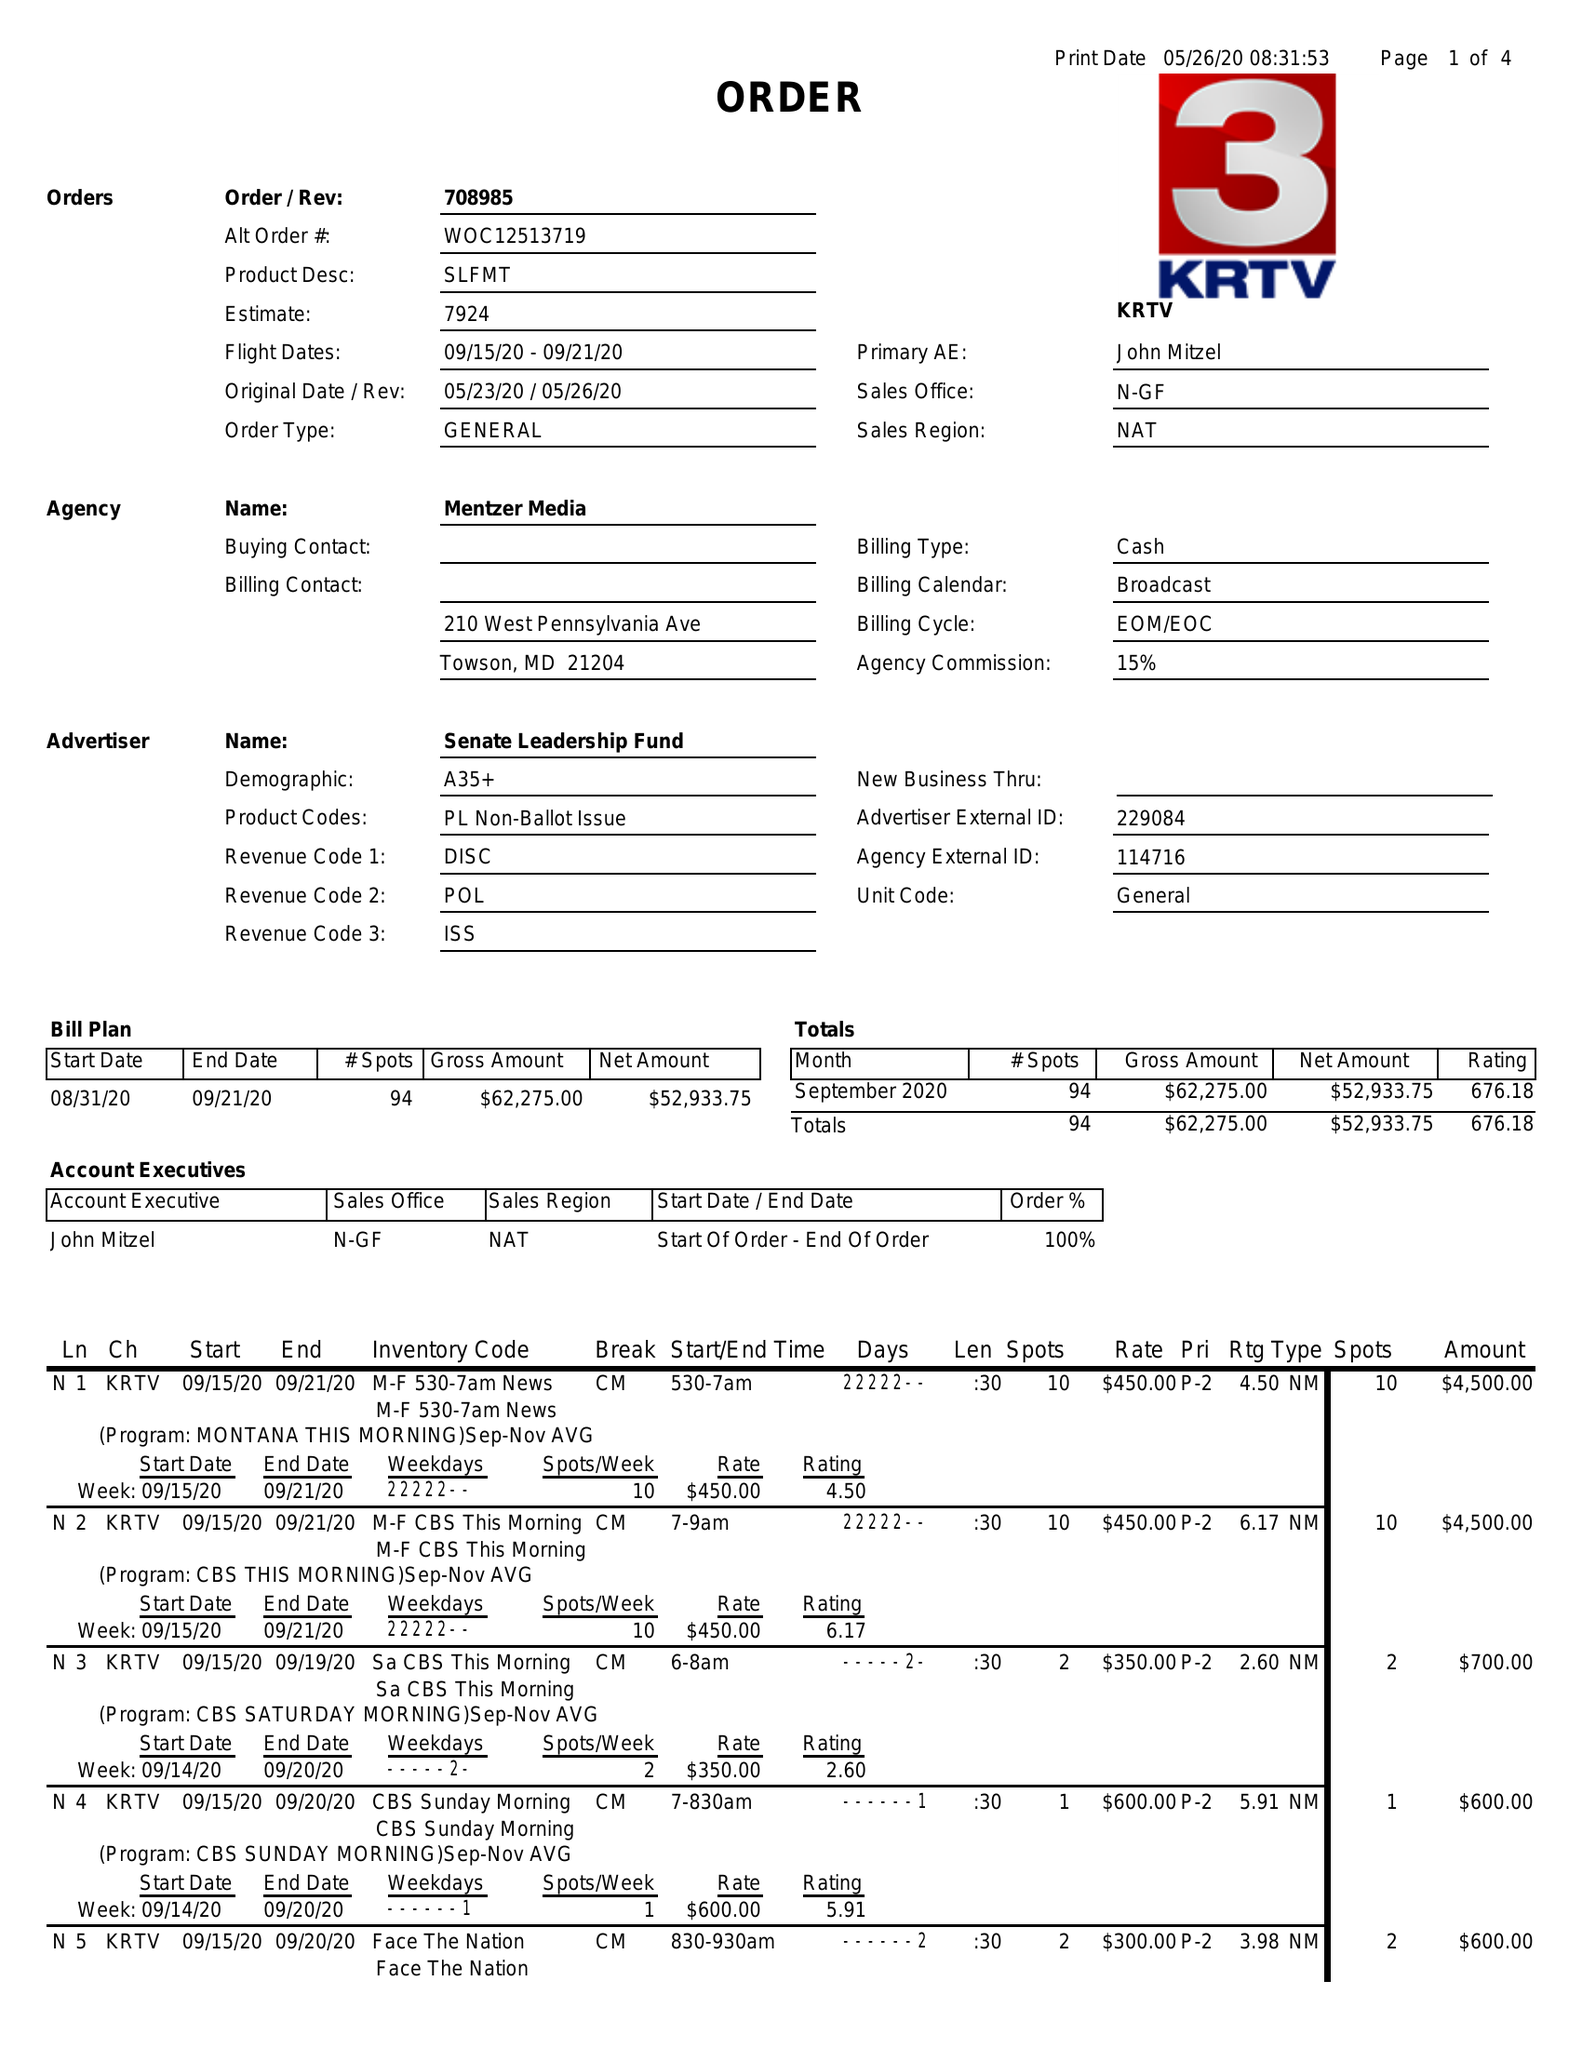What is the value for the flight_to?
Answer the question using a single word or phrase. 09/21/20 